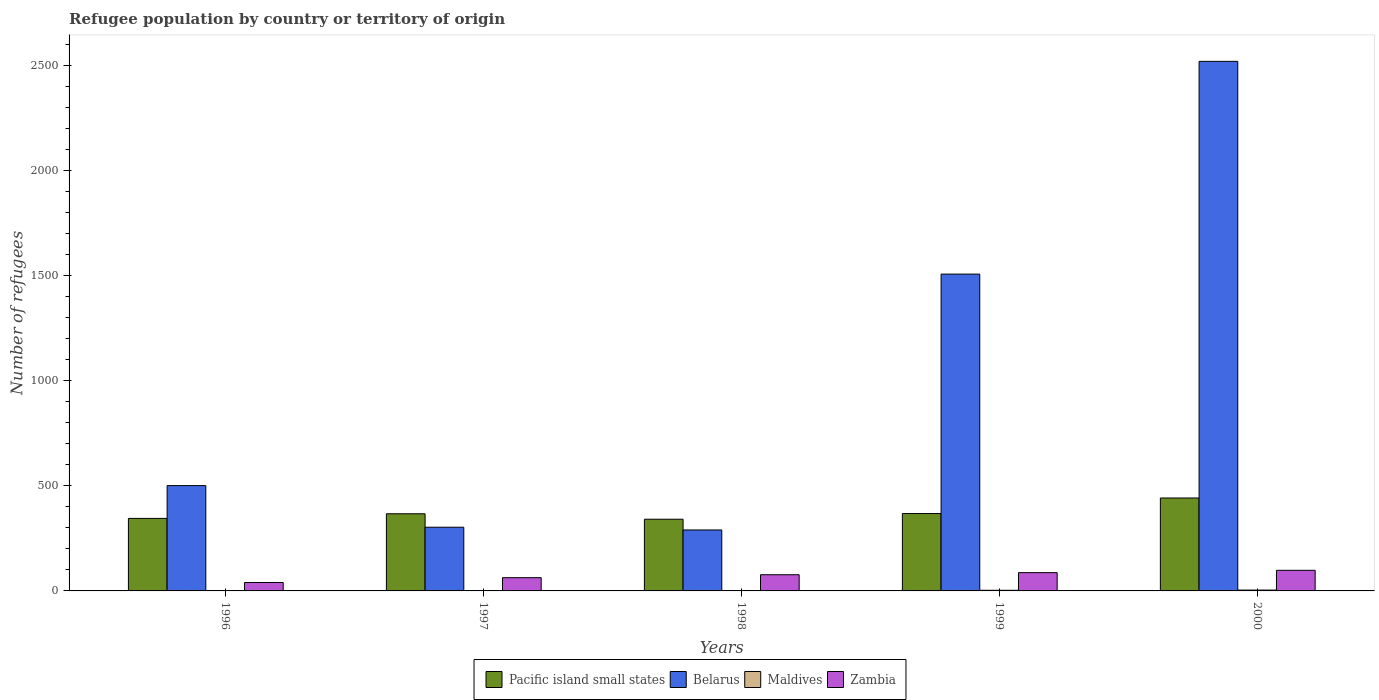How many groups of bars are there?
Give a very brief answer. 5. Are the number of bars per tick equal to the number of legend labels?
Keep it short and to the point. Yes. Are the number of bars on each tick of the X-axis equal?
Provide a succinct answer. Yes. How many bars are there on the 3rd tick from the left?
Your response must be concise. 4. In how many cases, is the number of bars for a given year not equal to the number of legend labels?
Your answer should be compact. 0. What is the number of refugees in Belarus in 2000?
Keep it short and to the point. 2519. Across all years, what is the maximum number of refugees in Belarus?
Provide a short and direct response. 2519. Across all years, what is the minimum number of refugees in Zambia?
Your answer should be very brief. 40. In which year was the number of refugees in Zambia maximum?
Give a very brief answer. 2000. What is the difference between the number of refugees in Maldives in 1997 and that in 2000?
Ensure brevity in your answer.  -3. What is the difference between the number of refugees in Zambia in 2000 and the number of refugees in Maldives in 1998?
Provide a succinct answer. 96. In the year 1996, what is the difference between the number of refugees in Zambia and number of refugees in Pacific island small states?
Offer a terse response. -305. In how many years, is the number of refugees in Belarus greater than 2400?
Keep it short and to the point. 1. What is the ratio of the number of refugees in Zambia in 1998 to that in 2000?
Make the answer very short. 0.79. Is the difference between the number of refugees in Zambia in 1996 and 1999 greater than the difference between the number of refugees in Pacific island small states in 1996 and 1999?
Make the answer very short. No. What is the difference between the highest and the second highest number of refugees in Pacific island small states?
Offer a terse response. 74. In how many years, is the number of refugees in Pacific island small states greater than the average number of refugees in Pacific island small states taken over all years?
Your answer should be compact. 1. What does the 2nd bar from the left in 2000 represents?
Offer a terse response. Belarus. What does the 2nd bar from the right in 1998 represents?
Your response must be concise. Maldives. Are all the bars in the graph horizontal?
Offer a terse response. No. How many years are there in the graph?
Ensure brevity in your answer.  5. What is the difference between two consecutive major ticks on the Y-axis?
Provide a short and direct response. 500. Does the graph contain any zero values?
Your answer should be compact. No. Does the graph contain grids?
Provide a succinct answer. No. How many legend labels are there?
Offer a very short reply. 4. How are the legend labels stacked?
Provide a succinct answer. Horizontal. What is the title of the graph?
Provide a succinct answer. Refugee population by country or territory of origin. Does "Niger" appear as one of the legend labels in the graph?
Your answer should be very brief. No. What is the label or title of the Y-axis?
Your answer should be very brief. Number of refugees. What is the Number of refugees of Pacific island small states in 1996?
Give a very brief answer. 345. What is the Number of refugees in Belarus in 1996?
Provide a short and direct response. 501. What is the Number of refugees in Maldives in 1996?
Give a very brief answer. 1. What is the Number of refugees in Zambia in 1996?
Your response must be concise. 40. What is the Number of refugees in Pacific island small states in 1997?
Provide a short and direct response. 367. What is the Number of refugees of Belarus in 1997?
Your response must be concise. 303. What is the Number of refugees of Maldives in 1997?
Offer a very short reply. 1. What is the Number of refugees in Pacific island small states in 1998?
Your answer should be compact. 341. What is the Number of refugees of Belarus in 1998?
Offer a terse response. 290. What is the Number of refugees in Maldives in 1998?
Ensure brevity in your answer.  2. What is the Number of refugees in Zambia in 1998?
Give a very brief answer. 77. What is the Number of refugees of Pacific island small states in 1999?
Provide a short and direct response. 368. What is the Number of refugees of Belarus in 1999?
Ensure brevity in your answer.  1507. What is the Number of refugees in Maldives in 1999?
Provide a short and direct response. 3. What is the Number of refugees of Pacific island small states in 2000?
Offer a very short reply. 442. What is the Number of refugees of Belarus in 2000?
Your response must be concise. 2519. What is the Number of refugees in Maldives in 2000?
Your answer should be compact. 4. Across all years, what is the maximum Number of refugees in Pacific island small states?
Make the answer very short. 442. Across all years, what is the maximum Number of refugees in Belarus?
Offer a very short reply. 2519. Across all years, what is the maximum Number of refugees in Zambia?
Your answer should be very brief. 98. Across all years, what is the minimum Number of refugees in Pacific island small states?
Give a very brief answer. 341. Across all years, what is the minimum Number of refugees of Belarus?
Offer a very short reply. 290. Across all years, what is the minimum Number of refugees of Zambia?
Your response must be concise. 40. What is the total Number of refugees in Pacific island small states in the graph?
Give a very brief answer. 1863. What is the total Number of refugees in Belarus in the graph?
Keep it short and to the point. 5120. What is the total Number of refugees of Zambia in the graph?
Keep it short and to the point. 365. What is the difference between the Number of refugees of Belarus in 1996 and that in 1997?
Your answer should be compact. 198. What is the difference between the Number of refugees in Maldives in 1996 and that in 1997?
Provide a short and direct response. 0. What is the difference between the Number of refugees in Belarus in 1996 and that in 1998?
Offer a very short reply. 211. What is the difference between the Number of refugees in Maldives in 1996 and that in 1998?
Provide a succinct answer. -1. What is the difference between the Number of refugees in Zambia in 1996 and that in 1998?
Make the answer very short. -37. What is the difference between the Number of refugees of Belarus in 1996 and that in 1999?
Give a very brief answer. -1006. What is the difference between the Number of refugees of Zambia in 1996 and that in 1999?
Make the answer very short. -47. What is the difference between the Number of refugees of Pacific island small states in 1996 and that in 2000?
Offer a very short reply. -97. What is the difference between the Number of refugees in Belarus in 1996 and that in 2000?
Offer a terse response. -2018. What is the difference between the Number of refugees of Zambia in 1996 and that in 2000?
Ensure brevity in your answer.  -58. What is the difference between the Number of refugees of Zambia in 1997 and that in 1998?
Provide a short and direct response. -14. What is the difference between the Number of refugees in Belarus in 1997 and that in 1999?
Provide a short and direct response. -1204. What is the difference between the Number of refugees of Zambia in 1997 and that in 1999?
Keep it short and to the point. -24. What is the difference between the Number of refugees in Pacific island small states in 1997 and that in 2000?
Your response must be concise. -75. What is the difference between the Number of refugees in Belarus in 1997 and that in 2000?
Your answer should be very brief. -2216. What is the difference between the Number of refugees of Maldives in 1997 and that in 2000?
Your answer should be very brief. -3. What is the difference between the Number of refugees in Zambia in 1997 and that in 2000?
Offer a very short reply. -35. What is the difference between the Number of refugees in Belarus in 1998 and that in 1999?
Keep it short and to the point. -1217. What is the difference between the Number of refugees of Zambia in 1998 and that in 1999?
Make the answer very short. -10. What is the difference between the Number of refugees in Pacific island small states in 1998 and that in 2000?
Provide a short and direct response. -101. What is the difference between the Number of refugees of Belarus in 1998 and that in 2000?
Your response must be concise. -2229. What is the difference between the Number of refugees of Maldives in 1998 and that in 2000?
Offer a terse response. -2. What is the difference between the Number of refugees in Pacific island small states in 1999 and that in 2000?
Offer a very short reply. -74. What is the difference between the Number of refugees of Belarus in 1999 and that in 2000?
Your response must be concise. -1012. What is the difference between the Number of refugees in Maldives in 1999 and that in 2000?
Your answer should be very brief. -1. What is the difference between the Number of refugees in Pacific island small states in 1996 and the Number of refugees in Belarus in 1997?
Offer a very short reply. 42. What is the difference between the Number of refugees of Pacific island small states in 1996 and the Number of refugees of Maldives in 1997?
Offer a very short reply. 344. What is the difference between the Number of refugees of Pacific island small states in 1996 and the Number of refugees of Zambia in 1997?
Ensure brevity in your answer.  282. What is the difference between the Number of refugees of Belarus in 1996 and the Number of refugees of Zambia in 1997?
Provide a succinct answer. 438. What is the difference between the Number of refugees in Maldives in 1996 and the Number of refugees in Zambia in 1997?
Provide a short and direct response. -62. What is the difference between the Number of refugees of Pacific island small states in 1996 and the Number of refugees of Maldives in 1998?
Give a very brief answer. 343. What is the difference between the Number of refugees of Pacific island small states in 1996 and the Number of refugees of Zambia in 1998?
Ensure brevity in your answer.  268. What is the difference between the Number of refugees of Belarus in 1996 and the Number of refugees of Maldives in 1998?
Give a very brief answer. 499. What is the difference between the Number of refugees of Belarus in 1996 and the Number of refugees of Zambia in 1998?
Provide a succinct answer. 424. What is the difference between the Number of refugees of Maldives in 1996 and the Number of refugees of Zambia in 1998?
Offer a very short reply. -76. What is the difference between the Number of refugees in Pacific island small states in 1996 and the Number of refugees in Belarus in 1999?
Offer a terse response. -1162. What is the difference between the Number of refugees in Pacific island small states in 1996 and the Number of refugees in Maldives in 1999?
Your answer should be very brief. 342. What is the difference between the Number of refugees of Pacific island small states in 1996 and the Number of refugees of Zambia in 1999?
Keep it short and to the point. 258. What is the difference between the Number of refugees in Belarus in 1996 and the Number of refugees in Maldives in 1999?
Provide a succinct answer. 498. What is the difference between the Number of refugees of Belarus in 1996 and the Number of refugees of Zambia in 1999?
Provide a succinct answer. 414. What is the difference between the Number of refugees in Maldives in 1996 and the Number of refugees in Zambia in 1999?
Give a very brief answer. -86. What is the difference between the Number of refugees in Pacific island small states in 1996 and the Number of refugees in Belarus in 2000?
Make the answer very short. -2174. What is the difference between the Number of refugees of Pacific island small states in 1996 and the Number of refugees of Maldives in 2000?
Provide a succinct answer. 341. What is the difference between the Number of refugees in Pacific island small states in 1996 and the Number of refugees in Zambia in 2000?
Ensure brevity in your answer.  247. What is the difference between the Number of refugees in Belarus in 1996 and the Number of refugees in Maldives in 2000?
Your response must be concise. 497. What is the difference between the Number of refugees in Belarus in 1996 and the Number of refugees in Zambia in 2000?
Ensure brevity in your answer.  403. What is the difference between the Number of refugees of Maldives in 1996 and the Number of refugees of Zambia in 2000?
Offer a very short reply. -97. What is the difference between the Number of refugees in Pacific island small states in 1997 and the Number of refugees in Belarus in 1998?
Your response must be concise. 77. What is the difference between the Number of refugees in Pacific island small states in 1997 and the Number of refugees in Maldives in 1998?
Your response must be concise. 365. What is the difference between the Number of refugees in Pacific island small states in 1997 and the Number of refugees in Zambia in 1998?
Provide a short and direct response. 290. What is the difference between the Number of refugees of Belarus in 1997 and the Number of refugees of Maldives in 1998?
Ensure brevity in your answer.  301. What is the difference between the Number of refugees of Belarus in 1997 and the Number of refugees of Zambia in 1998?
Provide a succinct answer. 226. What is the difference between the Number of refugees of Maldives in 1997 and the Number of refugees of Zambia in 1998?
Provide a short and direct response. -76. What is the difference between the Number of refugees of Pacific island small states in 1997 and the Number of refugees of Belarus in 1999?
Your answer should be compact. -1140. What is the difference between the Number of refugees in Pacific island small states in 1997 and the Number of refugees in Maldives in 1999?
Your answer should be very brief. 364. What is the difference between the Number of refugees in Pacific island small states in 1997 and the Number of refugees in Zambia in 1999?
Give a very brief answer. 280. What is the difference between the Number of refugees in Belarus in 1997 and the Number of refugees in Maldives in 1999?
Keep it short and to the point. 300. What is the difference between the Number of refugees of Belarus in 1997 and the Number of refugees of Zambia in 1999?
Your answer should be very brief. 216. What is the difference between the Number of refugees in Maldives in 1997 and the Number of refugees in Zambia in 1999?
Ensure brevity in your answer.  -86. What is the difference between the Number of refugees of Pacific island small states in 1997 and the Number of refugees of Belarus in 2000?
Your answer should be very brief. -2152. What is the difference between the Number of refugees in Pacific island small states in 1997 and the Number of refugees in Maldives in 2000?
Offer a terse response. 363. What is the difference between the Number of refugees in Pacific island small states in 1997 and the Number of refugees in Zambia in 2000?
Offer a terse response. 269. What is the difference between the Number of refugees of Belarus in 1997 and the Number of refugees of Maldives in 2000?
Provide a short and direct response. 299. What is the difference between the Number of refugees in Belarus in 1997 and the Number of refugees in Zambia in 2000?
Offer a very short reply. 205. What is the difference between the Number of refugees in Maldives in 1997 and the Number of refugees in Zambia in 2000?
Offer a terse response. -97. What is the difference between the Number of refugees of Pacific island small states in 1998 and the Number of refugees of Belarus in 1999?
Keep it short and to the point. -1166. What is the difference between the Number of refugees in Pacific island small states in 1998 and the Number of refugees in Maldives in 1999?
Keep it short and to the point. 338. What is the difference between the Number of refugees in Pacific island small states in 1998 and the Number of refugees in Zambia in 1999?
Ensure brevity in your answer.  254. What is the difference between the Number of refugees of Belarus in 1998 and the Number of refugees of Maldives in 1999?
Provide a succinct answer. 287. What is the difference between the Number of refugees in Belarus in 1998 and the Number of refugees in Zambia in 1999?
Your answer should be very brief. 203. What is the difference between the Number of refugees in Maldives in 1998 and the Number of refugees in Zambia in 1999?
Provide a succinct answer. -85. What is the difference between the Number of refugees in Pacific island small states in 1998 and the Number of refugees in Belarus in 2000?
Provide a succinct answer. -2178. What is the difference between the Number of refugees of Pacific island small states in 1998 and the Number of refugees of Maldives in 2000?
Give a very brief answer. 337. What is the difference between the Number of refugees in Pacific island small states in 1998 and the Number of refugees in Zambia in 2000?
Your answer should be very brief. 243. What is the difference between the Number of refugees of Belarus in 1998 and the Number of refugees of Maldives in 2000?
Your answer should be compact. 286. What is the difference between the Number of refugees in Belarus in 1998 and the Number of refugees in Zambia in 2000?
Make the answer very short. 192. What is the difference between the Number of refugees of Maldives in 1998 and the Number of refugees of Zambia in 2000?
Offer a terse response. -96. What is the difference between the Number of refugees of Pacific island small states in 1999 and the Number of refugees of Belarus in 2000?
Keep it short and to the point. -2151. What is the difference between the Number of refugees in Pacific island small states in 1999 and the Number of refugees in Maldives in 2000?
Your answer should be compact. 364. What is the difference between the Number of refugees of Pacific island small states in 1999 and the Number of refugees of Zambia in 2000?
Make the answer very short. 270. What is the difference between the Number of refugees of Belarus in 1999 and the Number of refugees of Maldives in 2000?
Make the answer very short. 1503. What is the difference between the Number of refugees in Belarus in 1999 and the Number of refugees in Zambia in 2000?
Offer a very short reply. 1409. What is the difference between the Number of refugees of Maldives in 1999 and the Number of refugees of Zambia in 2000?
Your answer should be very brief. -95. What is the average Number of refugees in Pacific island small states per year?
Your answer should be compact. 372.6. What is the average Number of refugees of Belarus per year?
Offer a very short reply. 1024. What is the average Number of refugees of Zambia per year?
Your answer should be very brief. 73. In the year 1996, what is the difference between the Number of refugees in Pacific island small states and Number of refugees in Belarus?
Your response must be concise. -156. In the year 1996, what is the difference between the Number of refugees of Pacific island small states and Number of refugees of Maldives?
Your response must be concise. 344. In the year 1996, what is the difference between the Number of refugees of Pacific island small states and Number of refugees of Zambia?
Give a very brief answer. 305. In the year 1996, what is the difference between the Number of refugees in Belarus and Number of refugees in Zambia?
Your answer should be compact. 461. In the year 1996, what is the difference between the Number of refugees in Maldives and Number of refugees in Zambia?
Keep it short and to the point. -39. In the year 1997, what is the difference between the Number of refugees of Pacific island small states and Number of refugees of Maldives?
Make the answer very short. 366. In the year 1997, what is the difference between the Number of refugees of Pacific island small states and Number of refugees of Zambia?
Provide a succinct answer. 304. In the year 1997, what is the difference between the Number of refugees in Belarus and Number of refugees in Maldives?
Provide a succinct answer. 302. In the year 1997, what is the difference between the Number of refugees in Belarus and Number of refugees in Zambia?
Offer a very short reply. 240. In the year 1997, what is the difference between the Number of refugees in Maldives and Number of refugees in Zambia?
Your answer should be very brief. -62. In the year 1998, what is the difference between the Number of refugees of Pacific island small states and Number of refugees of Maldives?
Keep it short and to the point. 339. In the year 1998, what is the difference between the Number of refugees in Pacific island small states and Number of refugees in Zambia?
Make the answer very short. 264. In the year 1998, what is the difference between the Number of refugees in Belarus and Number of refugees in Maldives?
Provide a succinct answer. 288. In the year 1998, what is the difference between the Number of refugees in Belarus and Number of refugees in Zambia?
Your response must be concise. 213. In the year 1998, what is the difference between the Number of refugees of Maldives and Number of refugees of Zambia?
Make the answer very short. -75. In the year 1999, what is the difference between the Number of refugees of Pacific island small states and Number of refugees of Belarus?
Offer a terse response. -1139. In the year 1999, what is the difference between the Number of refugees in Pacific island small states and Number of refugees in Maldives?
Keep it short and to the point. 365. In the year 1999, what is the difference between the Number of refugees of Pacific island small states and Number of refugees of Zambia?
Offer a very short reply. 281. In the year 1999, what is the difference between the Number of refugees of Belarus and Number of refugees of Maldives?
Provide a succinct answer. 1504. In the year 1999, what is the difference between the Number of refugees in Belarus and Number of refugees in Zambia?
Offer a terse response. 1420. In the year 1999, what is the difference between the Number of refugees of Maldives and Number of refugees of Zambia?
Keep it short and to the point. -84. In the year 2000, what is the difference between the Number of refugees in Pacific island small states and Number of refugees in Belarus?
Provide a succinct answer. -2077. In the year 2000, what is the difference between the Number of refugees in Pacific island small states and Number of refugees in Maldives?
Provide a succinct answer. 438. In the year 2000, what is the difference between the Number of refugees in Pacific island small states and Number of refugees in Zambia?
Give a very brief answer. 344. In the year 2000, what is the difference between the Number of refugees of Belarus and Number of refugees of Maldives?
Provide a short and direct response. 2515. In the year 2000, what is the difference between the Number of refugees of Belarus and Number of refugees of Zambia?
Give a very brief answer. 2421. In the year 2000, what is the difference between the Number of refugees of Maldives and Number of refugees of Zambia?
Provide a short and direct response. -94. What is the ratio of the Number of refugees of Pacific island small states in 1996 to that in 1997?
Make the answer very short. 0.94. What is the ratio of the Number of refugees in Belarus in 1996 to that in 1997?
Provide a short and direct response. 1.65. What is the ratio of the Number of refugees of Zambia in 1996 to that in 1997?
Offer a very short reply. 0.63. What is the ratio of the Number of refugees of Pacific island small states in 1996 to that in 1998?
Offer a very short reply. 1.01. What is the ratio of the Number of refugees of Belarus in 1996 to that in 1998?
Your answer should be compact. 1.73. What is the ratio of the Number of refugees in Zambia in 1996 to that in 1998?
Offer a terse response. 0.52. What is the ratio of the Number of refugees in Pacific island small states in 1996 to that in 1999?
Make the answer very short. 0.94. What is the ratio of the Number of refugees of Belarus in 1996 to that in 1999?
Offer a very short reply. 0.33. What is the ratio of the Number of refugees of Maldives in 1996 to that in 1999?
Your answer should be compact. 0.33. What is the ratio of the Number of refugees of Zambia in 1996 to that in 1999?
Ensure brevity in your answer.  0.46. What is the ratio of the Number of refugees of Pacific island small states in 1996 to that in 2000?
Keep it short and to the point. 0.78. What is the ratio of the Number of refugees in Belarus in 1996 to that in 2000?
Your response must be concise. 0.2. What is the ratio of the Number of refugees of Maldives in 1996 to that in 2000?
Provide a succinct answer. 0.25. What is the ratio of the Number of refugees of Zambia in 1996 to that in 2000?
Your response must be concise. 0.41. What is the ratio of the Number of refugees in Pacific island small states in 1997 to that in 1998?
Offer a terse response. 1.08. What is the ratio of the Number of refugees of Belarus in 1997 to that in 1998?
Your answer should be compact. 1.04. What is the ratio of the Number of refugees in Maldives in 1997 to that in 1998?
Offer a terse response. 0.5. What is the ratio of the Number of refugees of Zambia in 1997 to that in 1998?
Provide a short and direct response. 0.82. What is the ratio of the Number of refugees of Belarus in 1997 to that in 1999?
Your response must be concise. 0.2. What is the ratio of the Number of refugees of Zambia in 1997 to that in 1999?
Ensure brevity in your answer.  0.72. What is the ratio of the Number of refugees of Pacific island small states in 1997 to that in 2000?
Provide a short and direct response. 0.83. What is the ratio of the Number of refugees in Belarus in 1997 to that in 2000?
Give a very brief answer. 0.12. What is the ratio of the Number of refugees of Maldives in 1997 to that in 2000?
Your answer should be compact. 0.25. What is the ratio of the Number of refugees of Zambia in 1997 to that in 2000?
Ensure brevity in your answer.  0.64. What is the ratio of the Number of refugees in Pacific island small states in 1998 to that in 1999?
Your answer should be compact. 0.93. What is the ratio of the Number of refugees of Belarus in 1998 to that in 1999?
Provide a short and direct response. 0.19. What is the ratio of the Number of refugees in Maldives in 1998 to that in 1999?
Ensure brevity in your answer.  0.67. What is the ratio of the Number of refugees of Zambia in 1998 to that in 1999?
Your answer should be compact. 0.89. What is the ratio of the Number of refugees in Pacific island small states in 1998 to that in 2000?
Your answer should be compact. 0.77. What is the ratio of the Number of refugees of Belarus in 1998 to that in 2000?
Ensure brevity in your answer.  0.12. What is the ratio of the Number of refugees of Maldives in 1998 to that in 2000?
Make the answer very short. 0.5. What is the ratio of the Number of refugees of Zambia in 1998 to that in 2000?
Offer a terse response. 0.79. What is the ratio of the Number of refugees of Pacific island small states in 1999 to that in 2000?
Your answer should be very brief. 0.83. What is the ratio of the Number of refugees in Belarus in 1999 to that in 2000?
Make the answer very short. 0.6. What is the ratio of the Number of refugees in Maldives in 1999 to that in 2000?
Give a very brief answer. 0.75. What is the ratio of the Number of refugees of Zambia in 1999 to that in 2000?
Make the answer very short. 0.89. What is the difference between the highest and the second highest Number of refugees in Belarus?
Provide a short and direct response. 1012. What is the difference between the highest and the second highest Number of refugees of Maldives?
Your answer should be compact. 1. What is the difference between the highest and the lowest Number of refugees of Pacific island small states?
Your response must be concise. 101. What is the difference between the highest and the lowest Number of refugees in Belarus?
Give a very brief answer. 2229. What is the difference between the highest and the lowest Number of refugees in Maldives?
Provide a short and direct response. 3. What is the difference between the highest and the lowest Number of refugees of Zambia?
Provide a succinct answer. 58. 